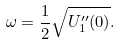<formula> <loc_0><loc_0><loc_500><loc_500>\omega = \frac { 1 } { 2 } \sqrt { U _ { 1 } ^ { \prime \prime } ( 0 ) } .</formula> 